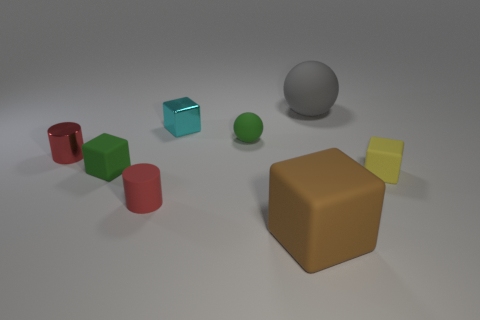Subtract 1 blocks. How many blocks are left? 3 Subtract all blue cubes. Subtract all cyan cylinders. How many cubes are left? 4 Add 2 large purple metallic spheres. How many objects exist? 10 Subtract all spheres. How many objects are left? 6 Add 7 tiny purple metallic blocks. How many tiny purple metallic blocks exist? 7 Subtract 1 green blocks. How many objects are left? 7 Subtract all brown things. Subtract all cylinders. How many objects are left? 5 Add 1 cylinders. How many cylinders are left? 3 